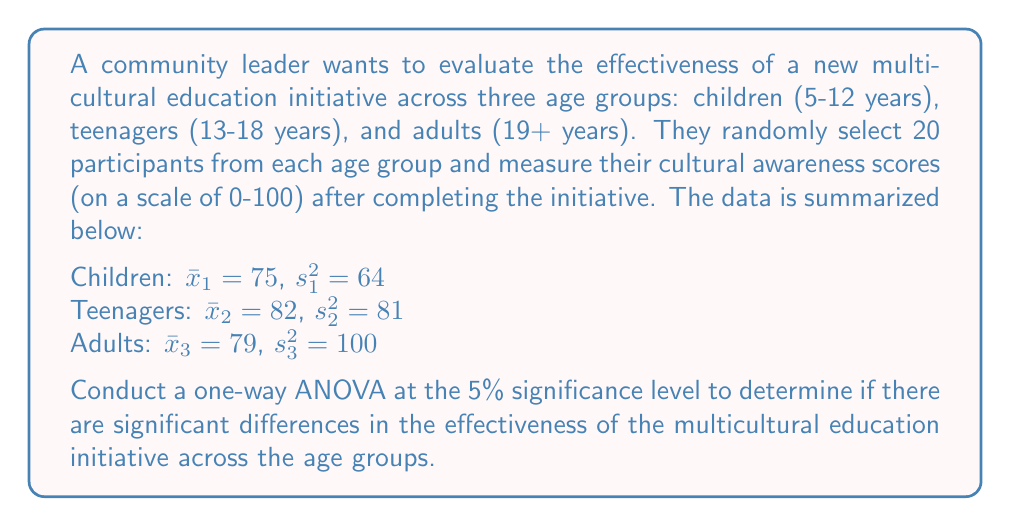Teach me how to tackle this problem. To conduct a one-way ANOVA, we'll follow these steps:

1. State the hypotheses:
   $H_0: \mu_1 = \mu_2 = \mu_3$ (no difference between age groups)
   $H_1:$ At least one mean is different

2. Calculate the between-groups sum of squares (SSB):
   $$SSB = \sum_{i=1}^k n_i(\bar{x}_i - \bar{x})^2$$
   where $k$ is the number of groups, $n_i$ is the sample size of each group, $\bar{x}_i$ is the mean of each group, and $\bar{x}$ is the grand mean.

   Grand mean: $\bar{x} = \frac{75 + 82 + 79}{3} = 78.67$

   $$SSB = 20(75 - 78.67)^2 + 20(82 - 78.67)^2 + 20(79 - 78.67)^2 = 490.67$$

3. Calculate the within-groups sum of squares (SSW):
   $$SSW = \sum_{i=1}^k (n_i - 1)s_i^2$$
   
   $$SSW = 19(64) + 19(81) + 19(100) = 4655$$

4. Calculate the total sum of squares (SST):
   $$SST = SSB + SSW = 490.67 + 4655 = 5145.67$$

5. Calculate degrees of freedom:
   Between-groups: $df_B = k - 1 = 3 - 1 = 2$
   Within-groups: $df_W = N - k = 60 - 3 = 57$
   Total: $df_T = N - 1 = 60 - 1 = 59$

6. Calculate mean squares:
   $$MSB = \frac{SSB}{df_B} = \frac{490.67}{2} = 245.34$$
   $$MSW = \frac{SSW}{df_W} = \frac{4655}{57} = 81.67$$

7. Calculate the F-statistic:
   $$F = \frac{MSB}{MSW} = \frac{245.34}{81.67} = 3.00$$

8. Find the critical F-value:
   For $\alpha = 0.05$, $df_B = 2$, and $df_W = 57$, the critical F-value is approximately 3.16.

9. Make a decision:
   Since the calculated F-statistic (3.00) is less than the critical F-value (3.16), we fail to reject the null hypothesis.
Answer: Fail to reject the null hypothesis. There is not enough evidence to conclude that there are significant differences in the effectiveness of the multicultural education initiative across the age groups at the 5% significance level (F = 3.00, F-critical = 3.16, p > 0.05). 